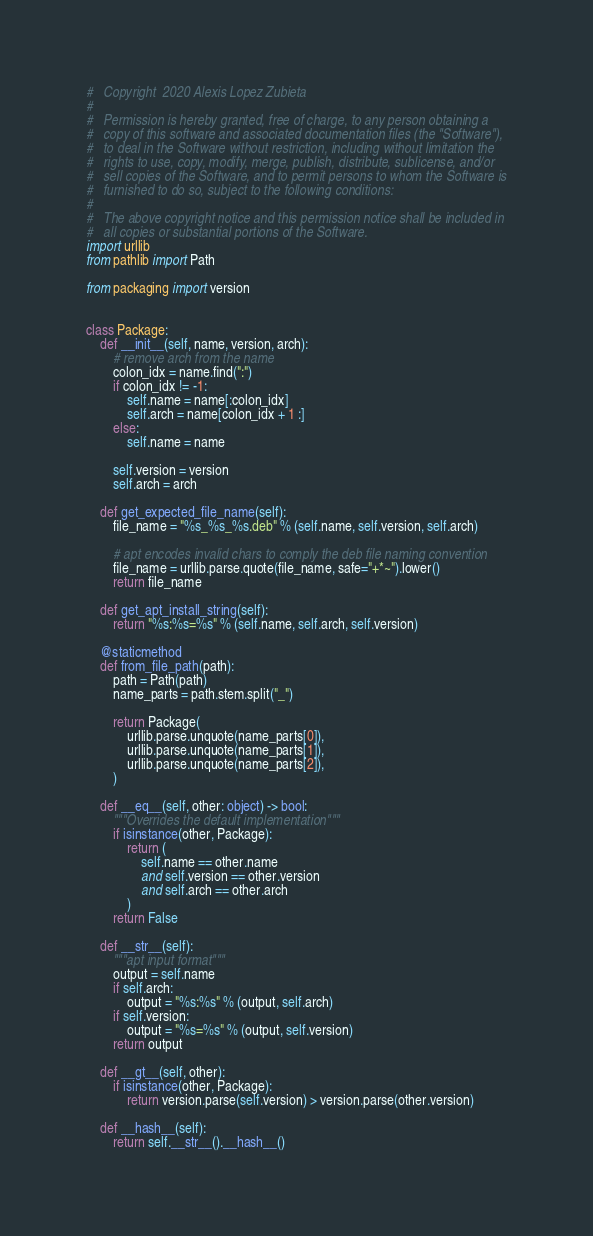Convert code to text. <code><loc_0><loc_0><loc_500><loc_500><_Python_>#   Copyright  2020 Alexis Lopez Zubieta
#
#   Permission is hereby granted, free of charge, to any person obtaining a
#   copy of this software and associated documentation files (the "Software"),
#   to deal in the Software without restriction, including without limitation the
#   rights to use, copy, modify, merge, publish, distribute, sublicense, and/or
#   sell copies of the Software, and to permit persons to whom the Software is
#   furnished to do so, subject to the following conditions:
#
#   The above copyright notice and this permission notice shall be included in
#   all copies or substantial portions of the Software.
import urllib
from pathlib import Path

from packaging import version


class Package:
    def __init__(self, name, version, arch):
        # remove arch from the name
        colon_idx = name.find(":")
        if colon_idx != -1:
            self.name = name[:colon_idx]
            self.arch = name[colon_idx + 1 :]
        else:
            self.name = name

        self.version = version
        self.arch = arch

    def get_expected_file_name(self):
        file_name = "%s_%s_%s.deb" % (self.name, self.version, self.arch)

        # apt encodes invalid chars to comply the deb file naming convention
        file_name = urllib.parse.quote(file_name, safe="+*~").lower()
        return file_name

    def get_apt_install_string(self):
        return "%s:%s=%s" % (self.name, self.arch, self.version)

    @staticmethod
    def from_file_path(path):
        path = Path(path)
        name_parts = path.stem.split("_")

        return Package(
            urllib.parse.unquote(name_parts[0]),
            urllib.parse.unquote(name_parts[1]),
            urllib.parse.unquote(name_parts[2]),
        )

    def __eq__(self, other: object) -> bool:
        """Overrides the default implementation"""
        if isinstance(other, Package):
            return (
                self.name == other.name
                and self.version == other.version
                and self.arch == other.arch
            )
        return False

    def __str__(self):
        """apt input format"""
        output = self.name
        if self.arch:
            output = "%s:%s" % (output, self.arch)
        if self.version:
            output = "%s=%s" % (output, self.version)
        return output

    def __gt__(self, other):
        if isinstance(other, Package):
            return version.parse(self.version) > version.parse(other.version)

    def __hash__(self):
        return self.__str__().__hash__()
</code> 